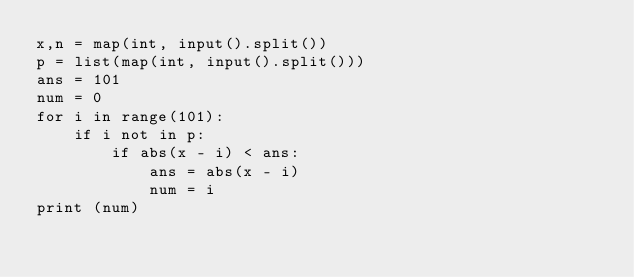<code> <loc_0><loc_0><loc_500><loc_500><_Python_>x,n = map(int, input().split())
p = list(map(int, input().split()))
ans = 101
num = 0
for i in range(101):
    if i not in p:
        if abs(x - i) < ans:
            ans = abs(x - i)
            num = i
print (num)</code> 